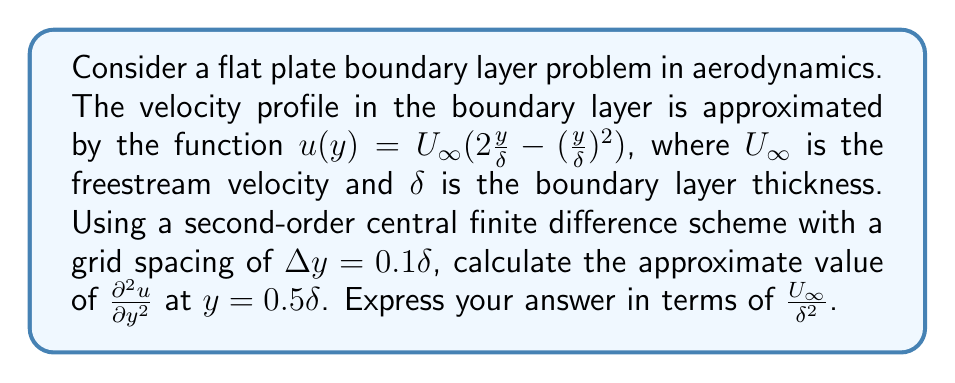Could you help me with this problem? Let's approach this step-by-step:

1) The second-order central finite difference approximation for the second derivative is:

   $$\frac{\partial^2 u}{\partial y^2} \approx \frac{u(y+\Delta y) - 2u(y) + u(y-\Delta y)}{(\Delta y)^2}$$

2) We need to calculate $u$ at three points: $y-\Delta y$, $y$, and $y+\Delta y$. Given $y = 0.5\delta$ and $\Delta y = 0.1\delta$:

   $y-\Delta y = 0.4\delta$
   $y = 0.5\delta$
   $y+\Delta y = 0.6\delta$

3) Let's calculate $u$ at these points using $u(y) = U_\infty(2\frac{y}{\delta} - (\frac{y}{\delta})^2)$:

   $u(0.4\delta) = U_\infty(2(0.4) - (0.4)^2) = U_\infty(0.8 - 0.16) = 0.64U_\infty$
   $u(0.5\delta) = U_\infty(2(0.5) - (0.5)^2) = U_\infty(1 - 0.25) = 0.75U_\infty$
   $u(0.6\delta) = U_\infty(2(0.6) - (0.6)^2) = U_\infty(1.2 - 0.36) = 0.84U_\infty$

4) Now, let's substitute these values into our finite difference formula:

   $$\frac{\partial^2 u}{\partial y^2} \approx \frac{0.84U_\infty - 2(0.75U_\infty) + 0.64U_\infty}{(0.1\delta)^2}$$

5) Simplify:

   $$\frac{\partial^2 u}{\partial y^2} \approx \frac{-0.02U_\infty}{0.01\delta^2} = -2\frac{U_\infty}{\delta^2}$$

Therefore, the approximate value of $\frac{\partial^2 u}{\partial y^2}$ at $y = 0.5\delta$ is $-2\frac{U_\infty}{\delta^2}$.
Answer: $-2\frac{U_\infty}{\delta^2}$ 